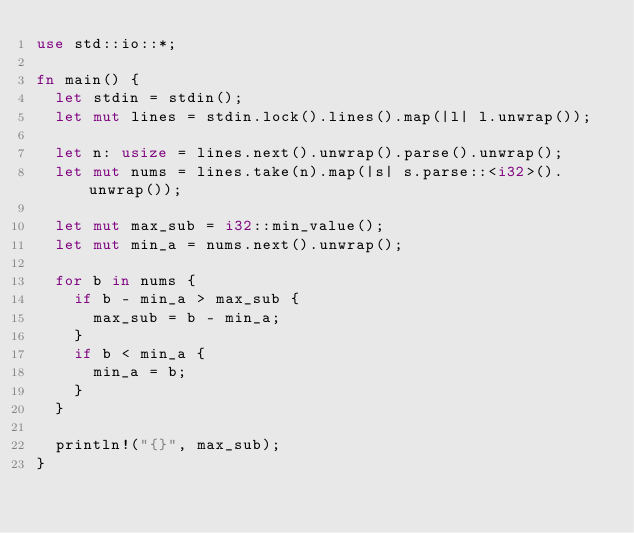Convert code to text. <code><loc_0><loc_0><loc_500><loc_500><_Rust_>use std::io::*;

fn main() {
  let stdin = stdin();
  let mut lines = stdin.lock().lines().map(|l| l.unwrap());

  let n: usize = lines.next().unwrap().parse().unwrap();
  let mut nums = lines.take(n).map(|s| s.parse::<i32>().unwrap());

  let mut max_sub = i32::min_value();
  let mut min_a = nums.next().unwrap();

  for b in nums {
    if b - min_a > max_sub {
      max_sub = b - min_a;
    }
    if b < min_a {
      min_a = b;
    }
  }

  println!("{}", max_sub);
}

</code> 